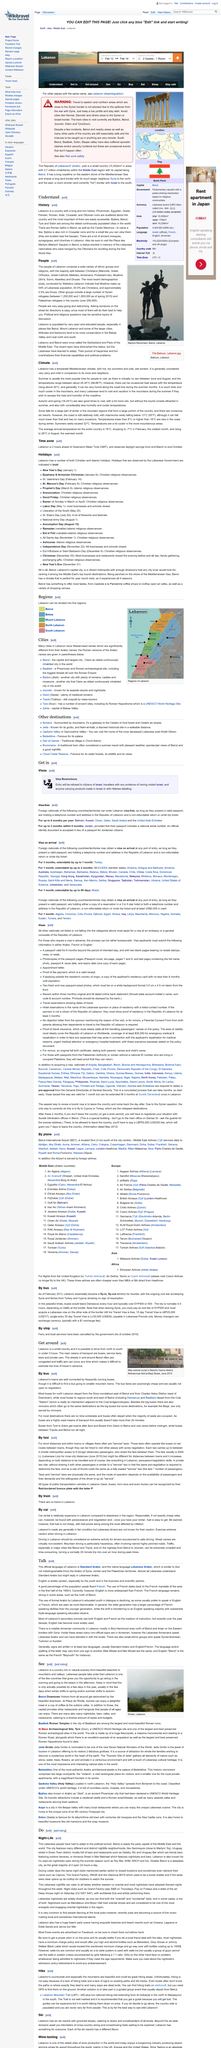Give some essential details in this illustration. The temperature during the hot, dry summer typically ranges between approximately 20-30°C (68-86°F). It is possible to go skiing in the morning and then go to the beach in the afternoon in Lebanon, but only for a limited period of time. Beirut and ehden are two cities located in Lebanon. The official language of the Lebanon is Standard Arabic, and the native language is Lebanese Arabic. The English language is widely spoken in Lebanon, especially by the youth and in the business and scientific sectors. 